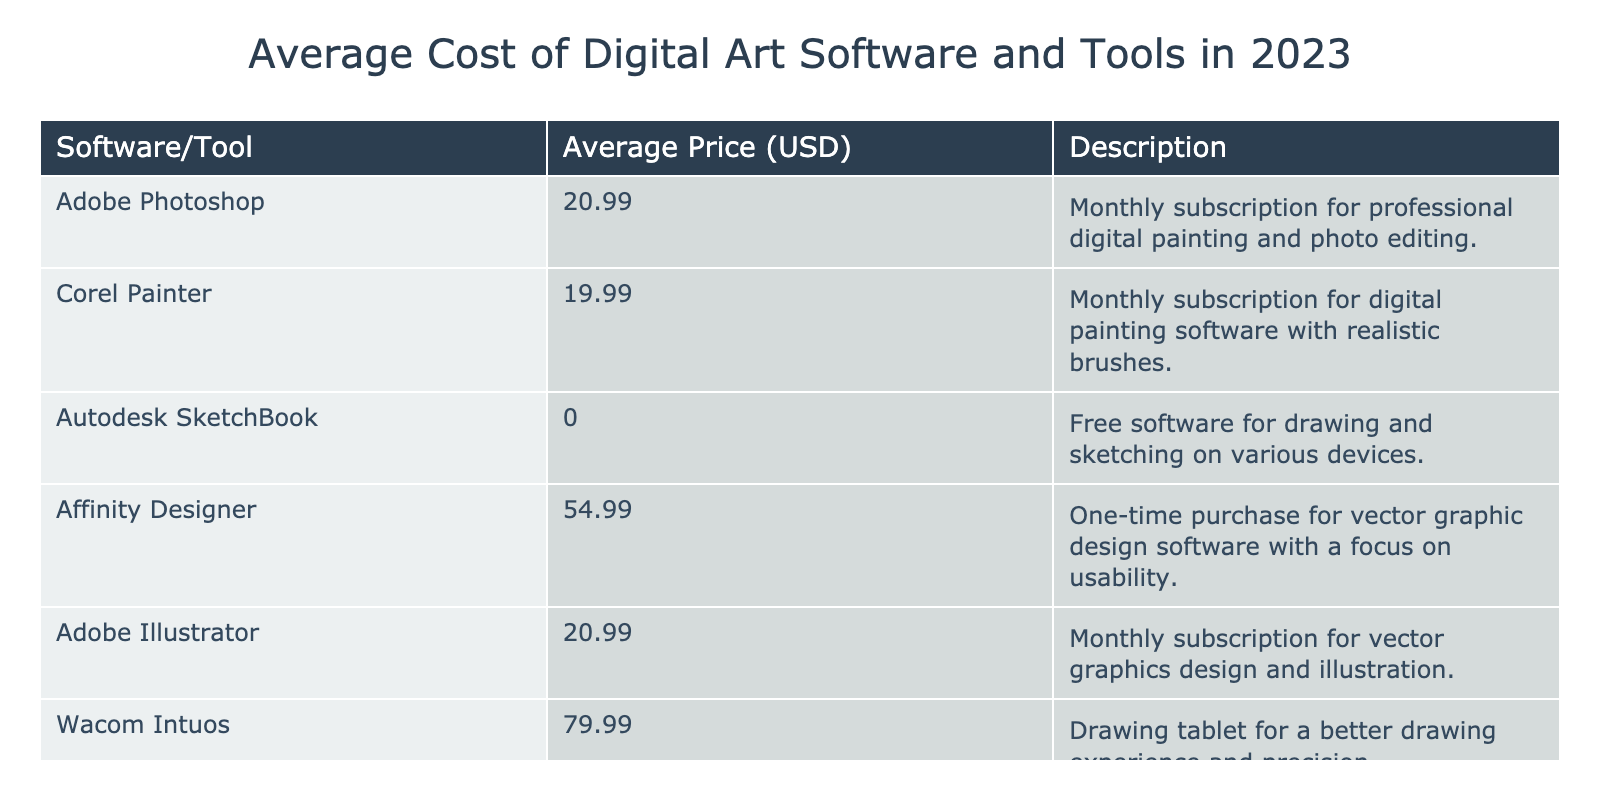What is the average price of Adobe Photoshop? According to the table, the price of Adobe Photoshop is listed as 20.99 USD.
Answer: 20.99 USD How much does Corel Painter cost? The table shows that Corel Painter has an average price of 19.99 USD.
Answer: 19.99 USD Is Autodesk SketchBook a paid software? The table indicates that Autodesk SketchBook has an average price of 0.00 USD, meaning it is free software.
Answer: No Which software has the highest average price? The table presents Wacom Intuos as having the highest average price at 79.99 USD, which is greater than others listed.
Answer: Wacom Intuos What is the total average cost of the two Adobe products listed? The prices for the two Adobe products are 20.99 USD (Photoshop) and 20.99 USD (Illustrator). Adding them gives 20.99 + 20.99 = 41.98 USD, so the total cost is 41.98 USD.
Answer: 41.98 USD Which software has the lowest average price besides free software? Looking through the expenses listed, Corel Painter at 19.99 USD is the lowest priced option excluding free software, which is Autodesk SketchBook.
Answer: Corel Painter What is the difference in price between Affinity Designer and Wacom Intuos? The price of Affinity Designer is 54.99 USD while Wacom Intuos is 79.99 USD. Calculating the difference: 79.99 - 54.99 = 25.00 USD. Therefore, the difference in price is 25.00 USD.
Answer: 25.00 USD Is it true that both Adobe Photoshop and Adobe Illustrator have the same price? By checking the table, both Adobe Photoshop and Adobe Illustrator are listed at 20.99 USD, confirming that they do indeed share the same price.
Answer: Yes If I purchased all the software listed, what would be my total expenditure? The total is calculated by summing all individual prices: 20.99 (Photoshop) + 19.99 (Corel Painter) + 0.00 (SketchBook) + 54.99 (Affinity Designer) + 20.99 (Illustrator) + 79.99 (Wacom Intuos) = 196.95 USD. Therefore, if you purchased all of them, you would spend 196.95 USD.
Answer: 196.95 USD 